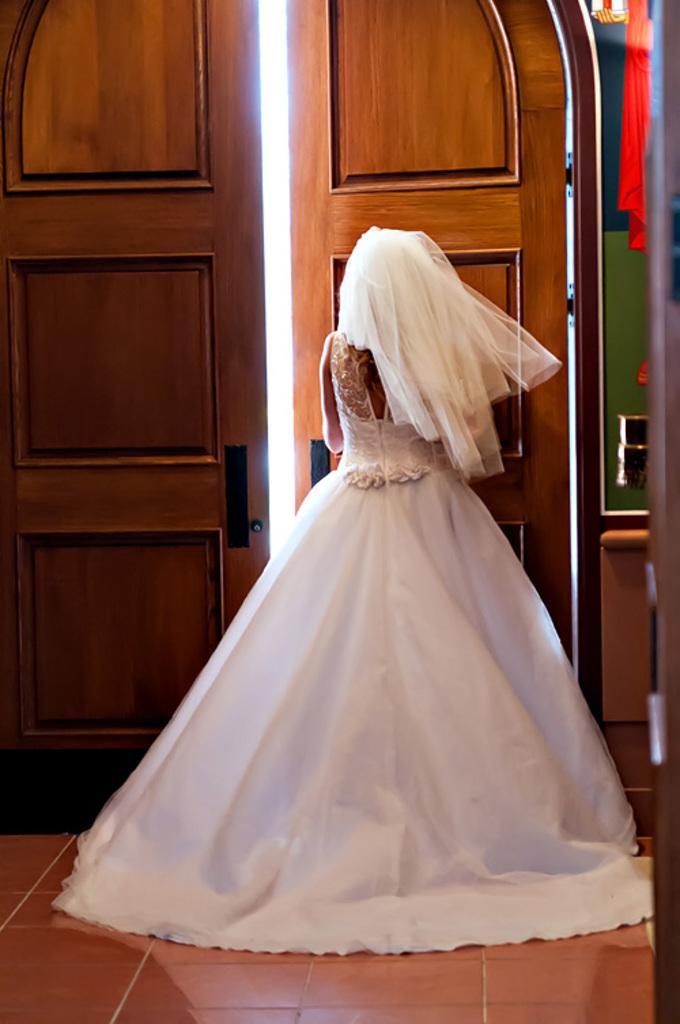Describe this image in one or two sentences. In this image there is a lady standing at the door. 